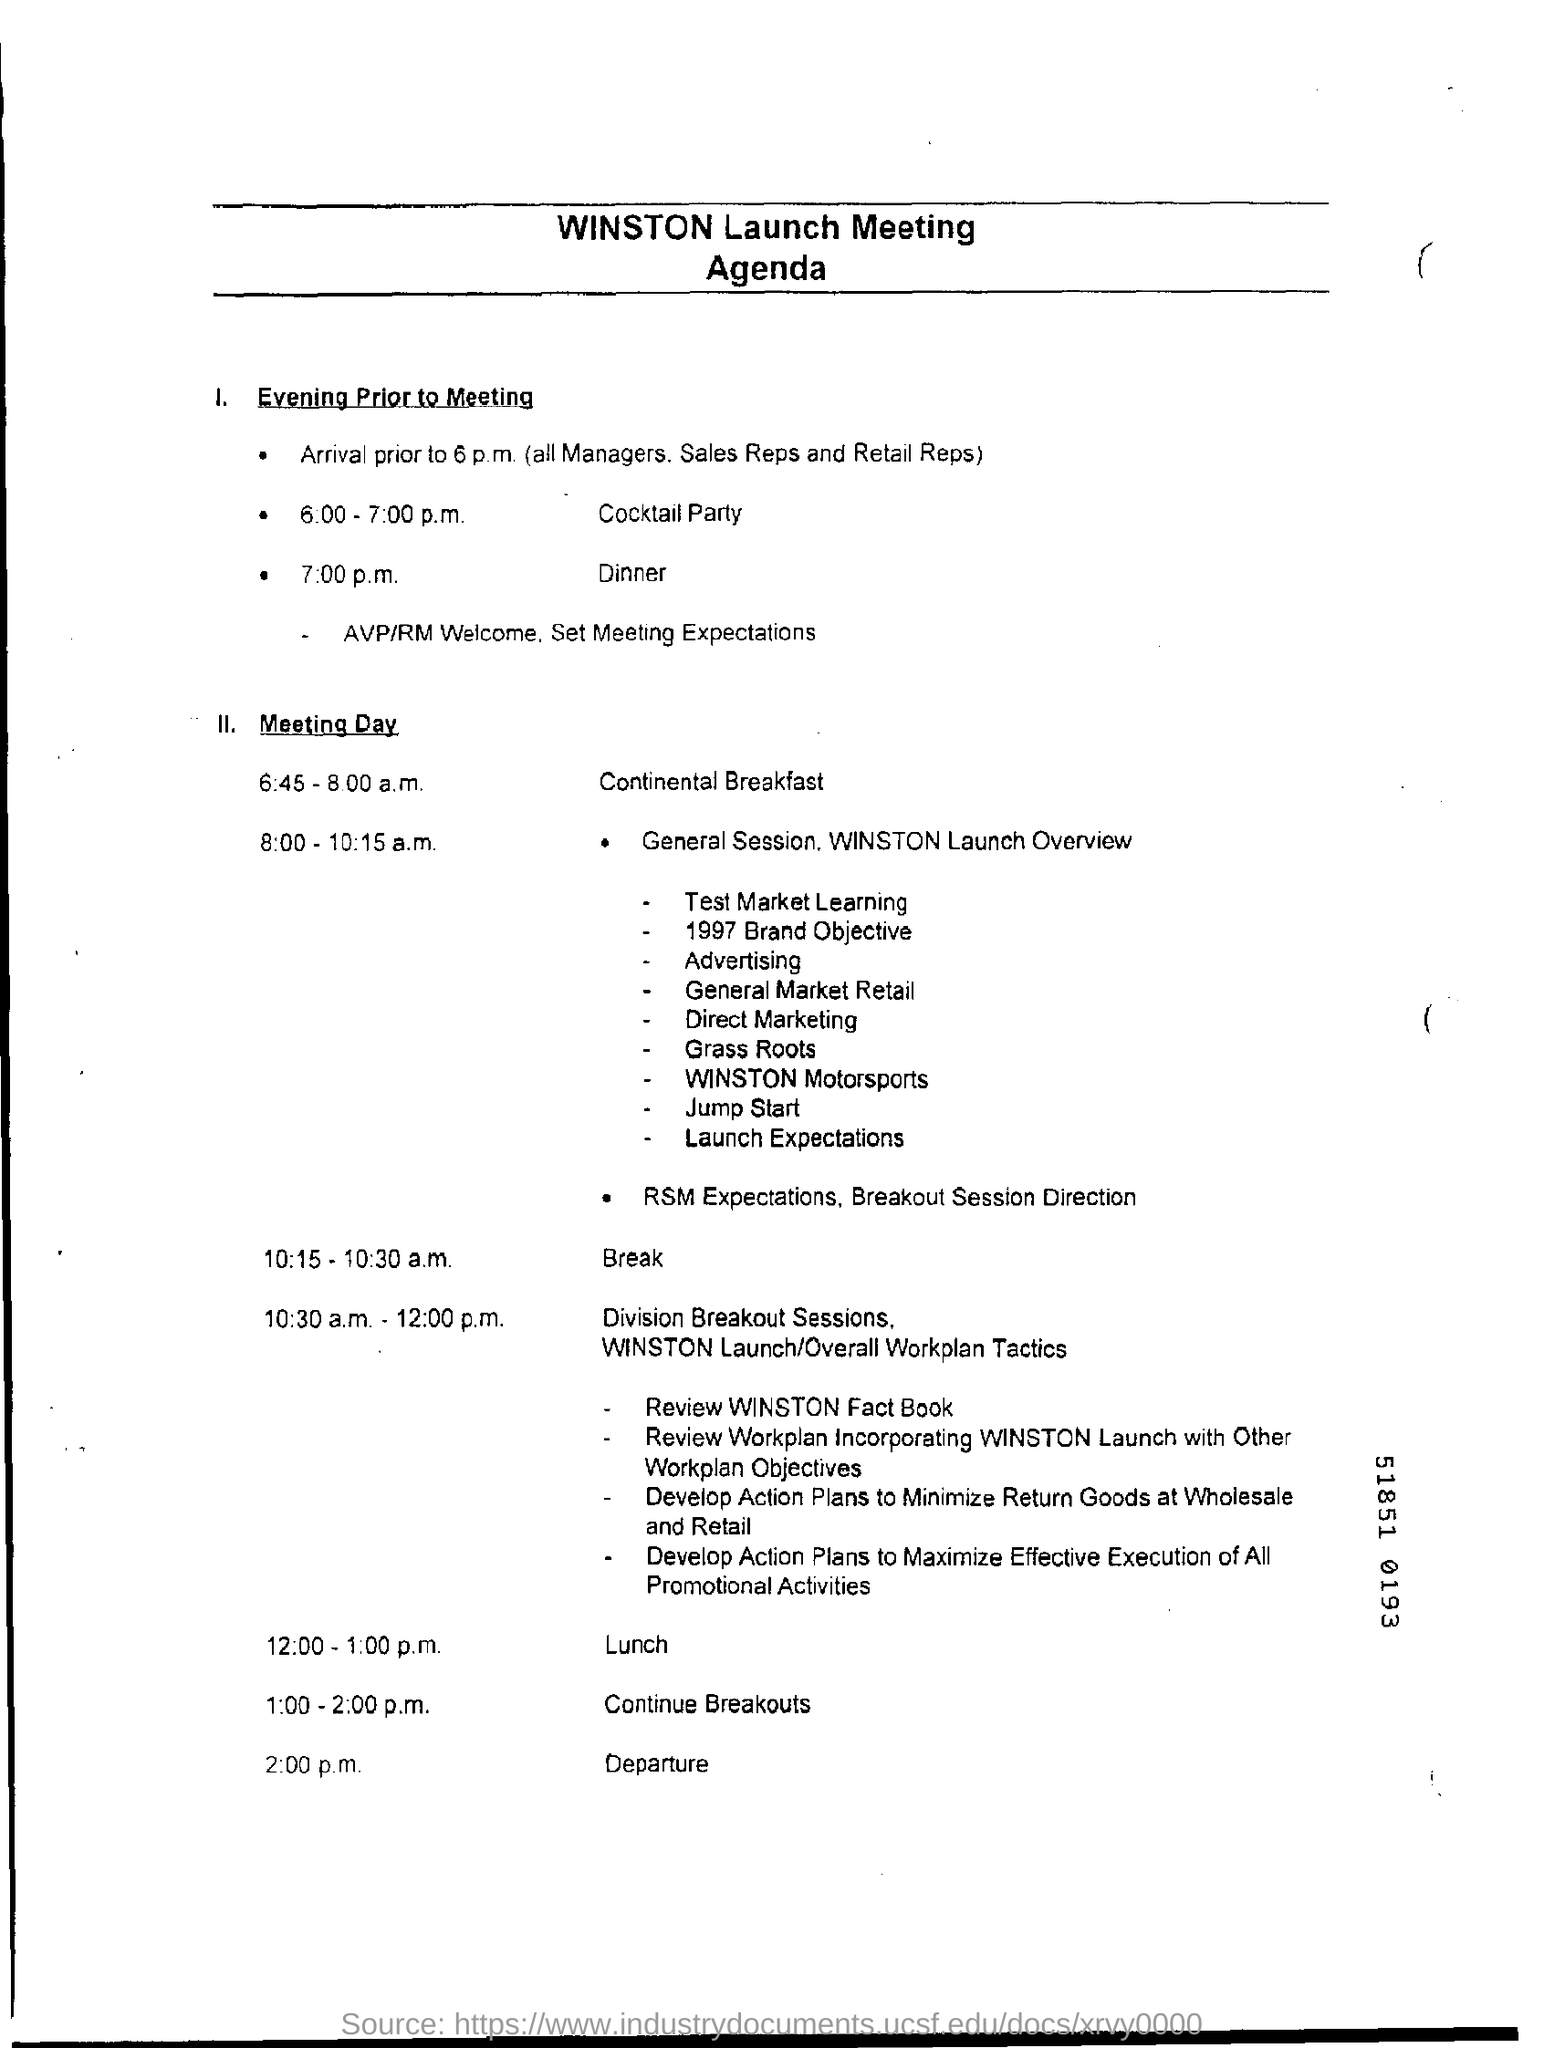Point out several critical features in this image. The cocktail party is scheduled to take place in the evening prior to the meeting, from 6:00 pm to 7:00 pm. The departure is scheduled for 2:00 p.m. 